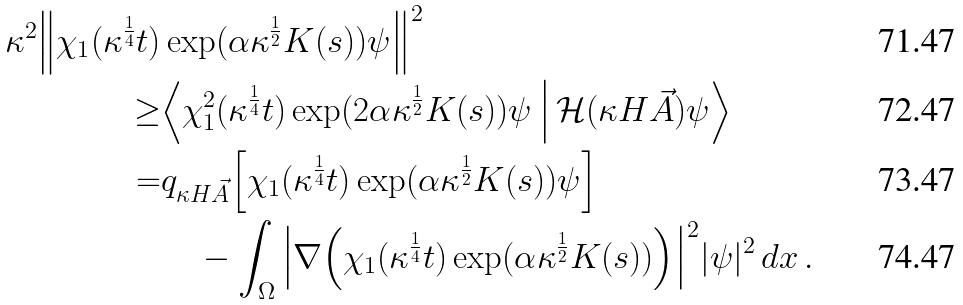<formula> <loc_0><loc_0><loc_500><loc_500>\kappa ^ { 2 } \Big \| \chi _ { 1 } ( \kappa ^ { \frac { 1 } { 4 } } t ) & \exp ( \alpha \kappa ^ { \frac { 1 } { 2 } } K ( s ) ) \psi \Big \| ^ { 2 } \\ \geq & \Big \langle \chi _ { 1 } ^ { 2 } ( \kappa ^ { \frac { 1 } { 4 } } t ) \exp ( 2 \alpha \kappa ^ { \frac { 1 } { 2 } } K ( s ) ) \psi \, \Big | \, { \mathcal { H } } ( \kappa H \vec { A } ) \psi \Big \rangle \\ = & q _ { \kappa H \vec { A } } \Big [ \chi _ { 1 } ( \kappa ^ { \frac { 1 } { 4 } } t ) \exp ( \alpha \kappa ^ { \frac { 1 } { 2 } } K ( s ) ) \psi \Big ] \\ & \quad - \int _ { \Omega } \Big | \nabla \Big ( \chi _ { 1 } ( \kappa ^ { \frac { 1 } { 4 } } t ) \exp ( \alpha \kappa ^ { \frac { 1 } { 2 } } K ( s ) ) \Big ) \Big | ^ { 2 } | \psi | ^ { 2 } \, d x \, .</formula> 